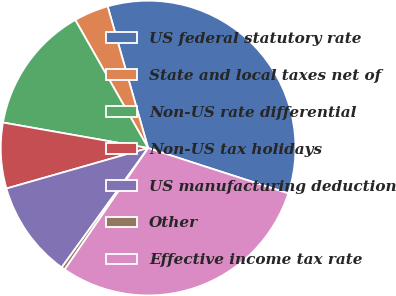Convert chart to OTSL. <chart><loc_0><loc_0><loc_500><loc_500><pie_chart><fcel>US federal statutory rate<fcel>State and local taxes net of<fcel>Non-US rate differential<fcel>Non-US tax holidays<fcel>US manufacturing deduction<fcel>Other<fcel>Effective income tax rate<nl><fcel>34.41%<fcel>3.8%<fcel>14.0%<fcel>7.2%<fcel>10.6%<fcel>0.39%<fcel>29.6%<nl></chart> 